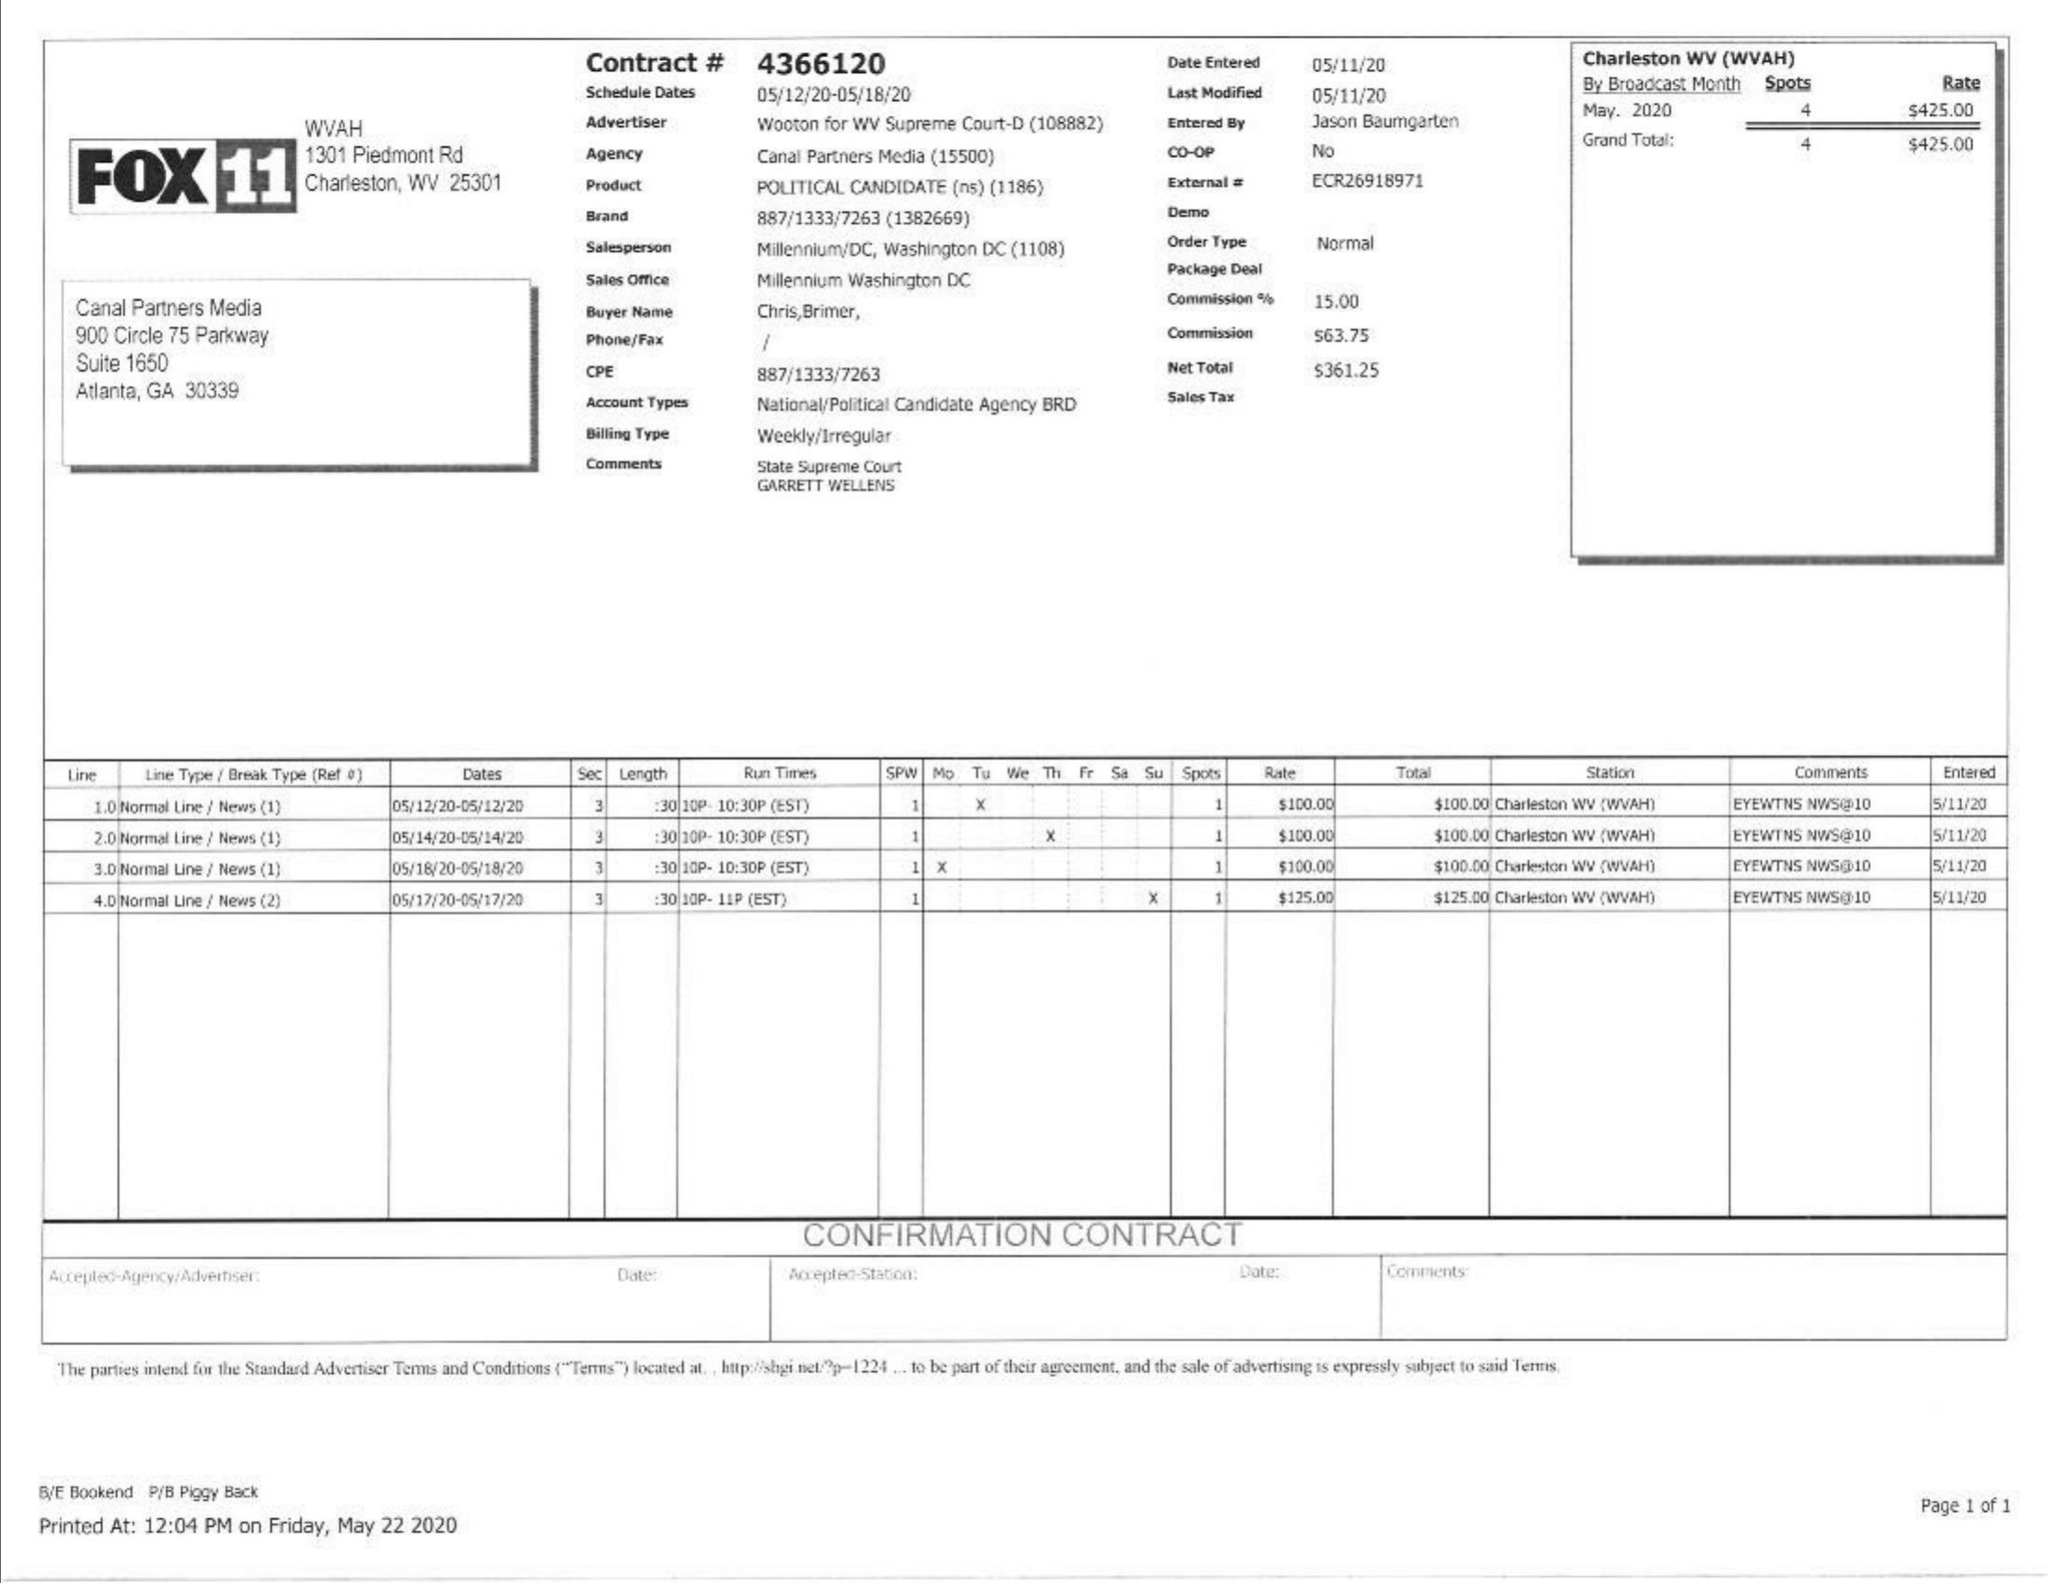What is the value for the flight_from?
Answer the question using a single word or phrase. 05/12/20 